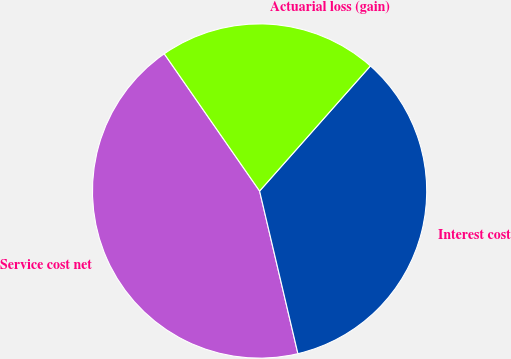Convert chart to OTSL. <chart><loc_0><loc_0><loc_500><loc_500><pie_chart><fcel>Service cost net<fcel>Interest cost<fcel>Actuarial loss (gain)<nl><fcel>44.02%<fcel>34.78%<fcel>21.2%<nl></chart> 